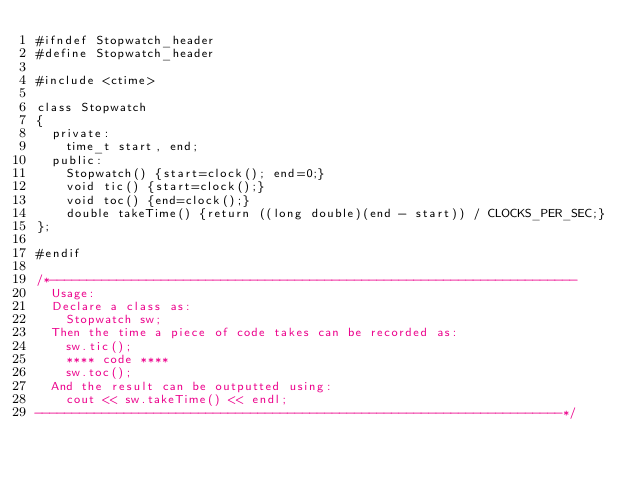<code> <loc_0><loc_0><loc_500><loc_500><_Cuda_>#ifndef Stopwatch_header
#define Stopwatch_header

#include <ctime>

class Stopwatch
{
  private:
    time_t start, end;
  public:
    Stopwatch() {start=clock(); end=0;}
    void tic() {start=clock();}
    void toc() {end=clock();}
    double takeTime() {return ((long double)(end - start)) / CLOCKS_PER_SEC;}
};

#endif

/*-----------------------------------------------------------------------
  Usage:
  Declare a class as:
    Stopwatch sw;
  Then the time a piece of code takes can be recorded as:
    sw.tic();
    **** code ****
    sw.toc();
  And the result can be outputted using:
    cout << sw.takeTime() << endl;
-----------------------------------------------------------------------*/
</code> 